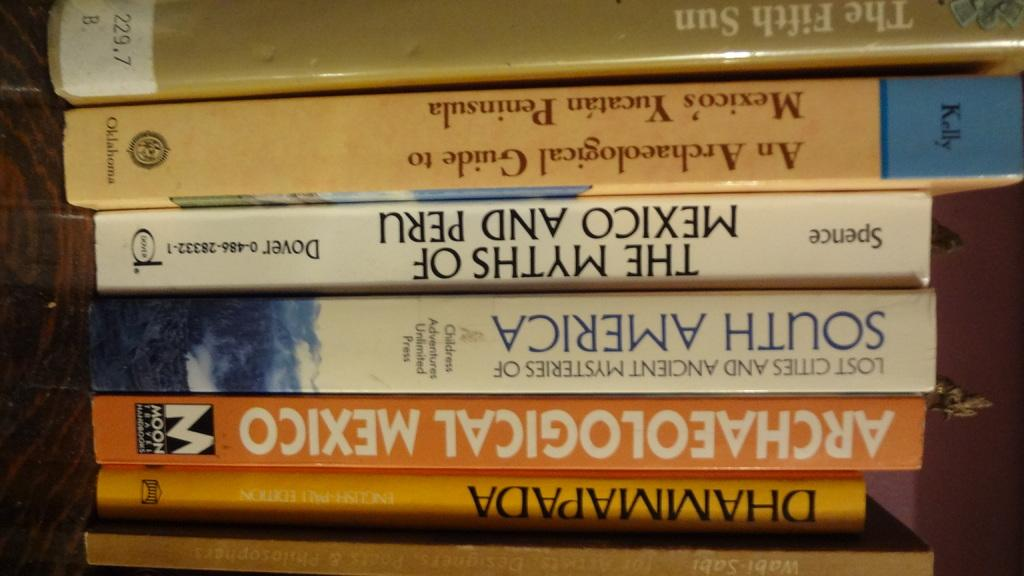<image>
Give a short and clear explanation of the subsequent image. A collection of books on a shelf includes the titles Archaelogical Mexido and The Fifth Sun. 